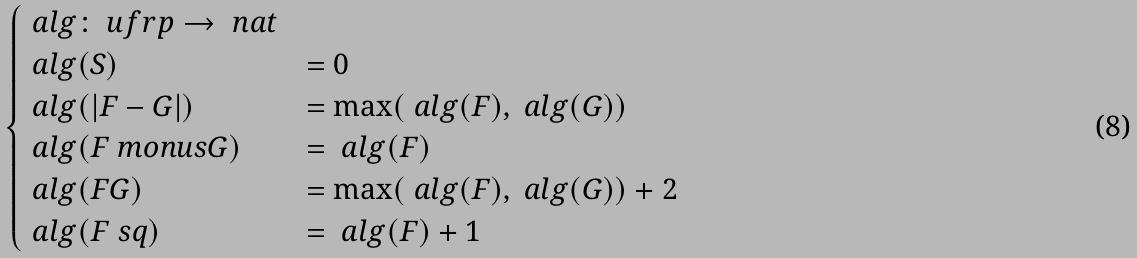Convert formula to latex. <formula><loc_0><loc_0><loc_500><loc_500>\begin{cases} \ a l g \colon \ u f r p \to \ n a t & \\ \ a l g ( S ) & = 0 \\ \ a l g ( | F - G | ) & = \max ( \ a l g ( F ) , \ a l g ( G ) ) \\ \ a l g ( F \ m o n u s G ) & = \ a l g ( F ) \\ \ a l g ( F G ) & = \max ( \ a l g ( F ) , \ a l g ( G ) ) + 2 \\ \ a l g ( F ^ { \ } s q ) & = \ a l g ( F ) + 1 \end{cases}</formula> 